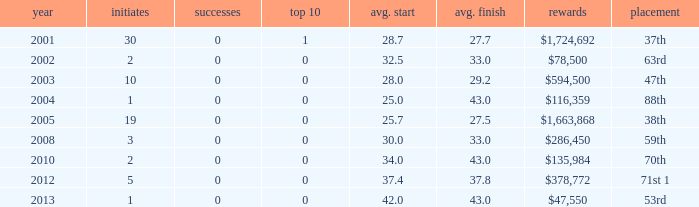How many wins for average start less than 25? 0.0. 